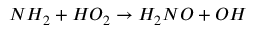Convert formula to latex. <formula><loc_0><loc_0><loc_500><loc_500>N H _ { 2 } + H O _ { 2 } \rightarrow H _ { 2 } N O + O H</formula> 